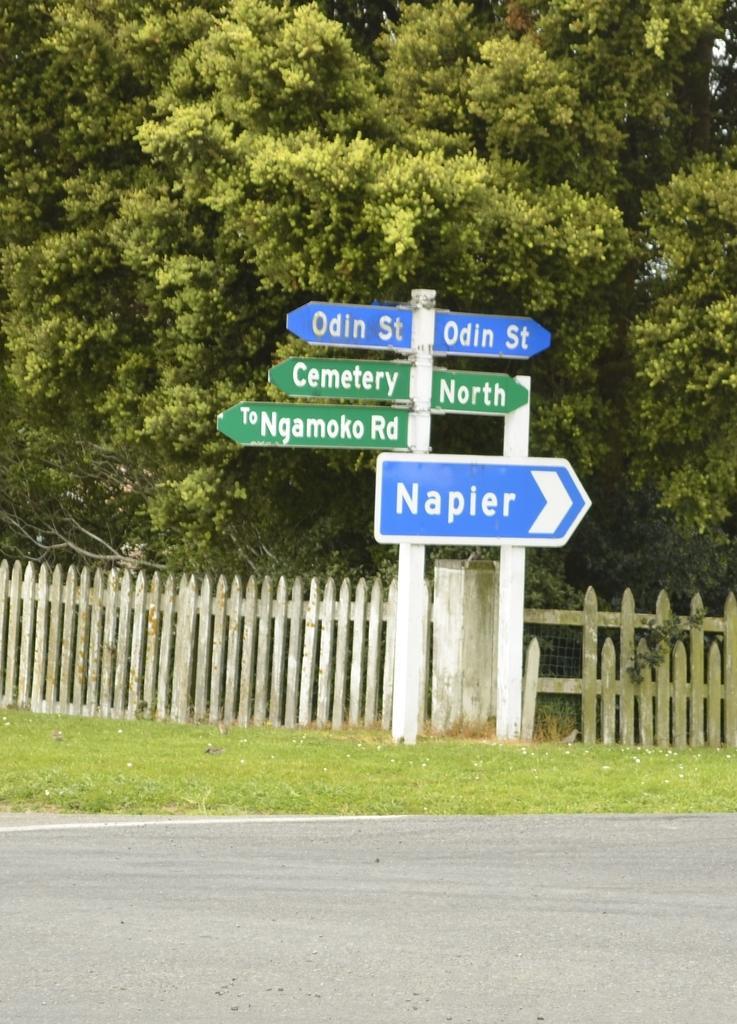How would you summarize this image in a sentence or two? In the middle of the picture, we see direction boards in blue and green color with some text written on it. At the bottom of the picture, we see the road and grass. Behind the board, we see a fence and there are trees in the background. 